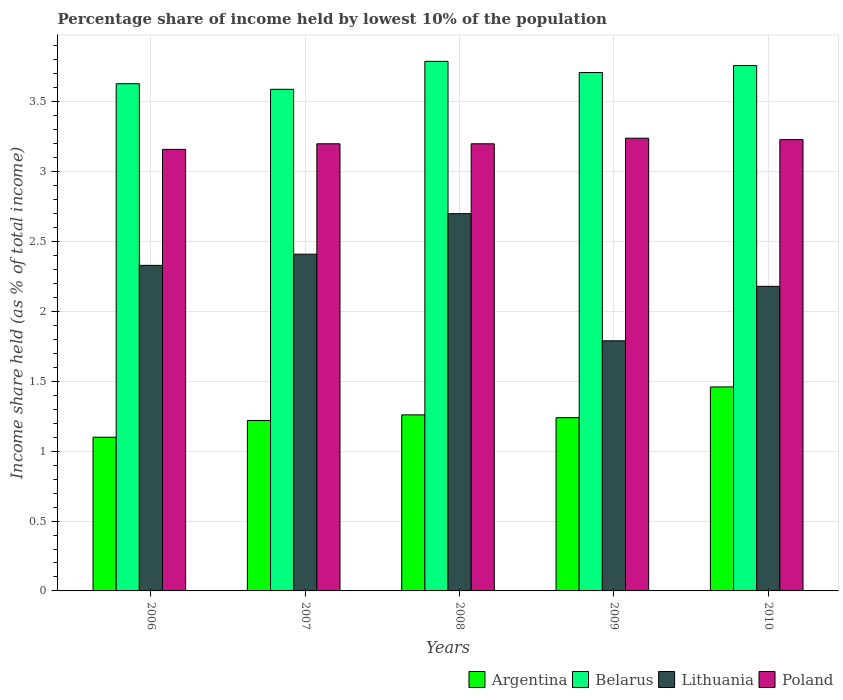How many bars are there on the 3rd tick from the left?
Offer a very short reply. 4. What is the percentage share of income held by lowest 10% of the population in Belarus in 2010?
Offer a very short reply. 3.76. Across all years, what is the minimum percentage share of income held by lowest 10% of the population in Poland?
Provide a succinct answer. 3.16. In which year was the percentage share of income held by lowest 10% of the population in Belarus maximum?
Provide a succinct answer. 2008. In which year was the percentage share of income held by lowest 10% of the population in Belarus minimum?
Your response must be concise. 2007. What is the total percentage share of income held by lowest 10% of the population in Belarus in the graph?
Provide a short and direct response. 18.48. What is the difference between the percentage share of income held by lowest 10% of the population in Poland in 2008 and that in 2010?
Ensure brevity in your answer.  -0.03. What is the difference between the percentage share of income held by lowest 10% of the population in Argentina in 2008 and the percentage share of income held by lowest 10% of the population in Lithuania in 2006?
Your answer should be very brief. -1.07. What is the average percentage share of income held by lowest 10% of the population in Belarus per year?
Ensure brevity in your answer.  3.7. In the year 2007, what is the difference between the percentage share of income held by lowest 10% of the population in Poland and percentage share of income held by lowest 10% of the population in Belarus?
Keep it short and to the point. -0.39. In how many years, is the percentage share of income held by lowest 10% of the population in Argentina greater than 3.8 %?
Keep it short and to the point. 0. What is the ratio of the percentage share of income held by lowest 10% of the population in Poland in 2006 to that in 2007?
Provide a succinct answer. 0.99. Is the percentage share of income held by lowest 10% of the population in Poland in 2007 less than that in 2008?
Ensure brevity in your answer.  No. What is the difference between the highest and the second highest percentage share of income held by lowest 10% of the population in Poland?
Make the answer very short. 0.01. What is the difference between the highest and the lowest percentage share of income held by lowest 10% of the population in Lithuania?
Your answer should be compact. 0.91. In how many years, is the percentage share of income held by lowest 10% of the population in Lithuania greater than the average percentage share of income held by lowest 10% of the population in Lithuania taken over all years?
Offer a very short reply. 3. Is it the case that in every year, the sum of the percentage share of income held by lowest 10% of the population in Argentina and percentage share of income held by lowest 10% of the population in Poland is greater than the sum of percentage share of income held by lowest 10% of the population in Belarus and percentage share of income held by lowest 10% of the population in Lithuania?
Provide a succinct answer. No. What does the 2nd bar from the left in 2009 represents?
Provide a succinct answer. Belarus. How many bars are there?
Your answer should be very brief. 20. How many years are there in the graph?
Ensure brevity in your answer.  5. What is the difference between two consecutive major ticks on the Y-axis?
Make the answer very short. 0.5. Are the values on the major ticks of Y-axis written in scientific E-notation?
Your response must be concise. No. Does the graph contain any zero values?
Your answer should be compact. No. Does the graph contain grids?
Ensure brevity in your answer.  Yes. What is the title of the graph?
Ensure brevity in your answer.  Percentage share of income held by lowest 10% of the population. What is the label or title of the Y-axis?
Provide a short and direct response. Income share held (as % of total income). What is the Income share held (as % of total income) of Argentina in 2006?
Ensure brevity in your answer.  1.1. What is the Income share held (as % of total income) in Belarus in 2006?
Your response must be concise. 3.63. What is the Income share held (as % of total income) of Lithuania in 2006?
Your answer should be very brief. 2.33. What is the Income share held (as % of total income) of Poland in 2006?
Keep it short and to the point. 3.16. What is the Income share held (as % of total income) in Argentina in 2007?
Give a very brief answer. 1.22. What is the Income share held (as % of total income) of Belarus in 2007?
Make the answer very short. 3.59. What is the Income share held (as % of total income) of Lithuania in 2007?
Your answer should be compact. 2.41. What is the Income share held (as % of total income) in Argentina in 2008?
Provide a short and direct response. 1.26. What is the Income share held (as % of total income) in Belarus in 2008?
Your answer should be very brief. 3.79. What is the Income share held (as % of total income) of Poland in 2008?
Keep it short and to the point. 3.2. What is the Income share held (as % of total income) in Argentina in 2009?
Your response must be concise. 1.24. What is the Income share held (as % of total income) in Belarus in 2009?
Offer a very short reply. 3.71. What is the Income share held (as % of total income) in Lithuania in 2009?
Keep it short and to the point. 1.79. What is the Income share held (as % of total income) in Poland in 2009?
Provide a short and direct response. 3.24. What is the Income share held (as % of total income) in Argentina in 2010?
Your answer should be very brief. 1.46. What is the Income share held (as % of total income) of Belarus in 2010?
Provide a succinct answer. 3.76. What is the Income share held (as % of total income) of Lithuania in 2010?
Offer a terse response. 2.18. What is the Income share held (as % of total income) in Poland in 2010?
Offer a very short reply. 3.23. Across all years, what is the maximum Income share held (as % of total income) of Argentina?
Keep it short and to the point. 1.46. Across all years, what is the maximum Income share held (as % of total income) in Belarus?
Make the answer very short. 3.79. Across all years, what is the maximum Income share held (as % of total income) of Lithuania?
Offer a terse response. 2.7. Across all years, what is the maximum Income share held (as % of total income) of Poland?
Keep it short and to the point. 3.24. Across all years, what is the minimum Income share held (as % of total income) in Argentina?
Provide a succinct answer. 1.1. Across all years, what is the minimum Income share held (as % of total income) of Belarus?
Ensure brevity in your answer.  3.59. Across all years, what is the minimum Income share held (as % of total income) in Lithuania?
Provide a succinct answer. 1.79. Across all years, what is the minimum Income share held (as % of total income) in Poland?
Provide a short and direct response. 3.16. What is the total Income share held (as % of total income) of Argentina in the graph?
Your answer should be very brief. 6.28. What is the total Income share held (as % of total income) of Belarus in the graph?
Keep it short and to the point. 18.48. What is the total Income share held (as % of total income) of Lithuania in the graph?
Give a very brief answer. 11.41. What is the total Income share held (as % of total income) in Poland in the graph?
Ensure brevity in your answer.  16.03. What is the difference between the Income share held (as % of total income) of Argentina in 2006 and that in 2007?
Provide a succinct answer. -0.12. What is the difference between the Income share held (as % of total income) of Belarus in 2006 and that in 2007?
Ensure brevity in your answer.  0.04. What is the difference between the Income share held (as % of total income) of Lithuania in 2006 and that in 2007?
Provide a succinct answer. -0.08. What is the difference between the Income share held (as % of total income) in Poland in 2006 and that in 2007?
Make the answer very short. -0.04. What is the difference between the Income share held (as % of total income) of Argentina in 2006 and that in 2008?
Offer a very short reply. -0.16. What is the difference between the Income share held (as % of total income) of Belarus in 2006 and that in 2008?
Make the answer very short. -0.16. What is the difference between the Income share held (as % of total income) of Lithuania in 2006 and that in 2008?
Your answer should be compact. -0.37. What is the difference between the Income share held (as % of total income) in Poland in 2006 and that in 2008?
Provide a succinct answer. -0.04. What is the difference between the Income share held (as % of total income) in Argentina in 2006 and that in 2009?
Ensure brevity in your answer.  -0.14. What is the difference between the Income share held (as % of total income) in Belarus in 2006 and that in 2009?
Provide a short and direct response. -0.08. What is the difference between the Income share held (as % of total income) in Lithuania in 2006 and that in 2009?
Your answer should be very brief. 0.54. What is the difference between the Income share held (as % of total income) of Poland in 2006 and that in 2009?
Offer a terse response. -0.08. What is the difference between the Income share held (as % of total income) of Argentina in 2006 and that in 2010?
Ensure brevity in your answer.  -0.36. What is the difference between the Income share held (as % of total income) in Belarus in 2006 and that in 2010?
Keep it short and to the point. -0.13. What is the difference between the Income share held (as % of total income) in Poland in 2006 and that in 2010?
Keep it short and to the point. -0.07. What is the difference between the Income share held (as % of total income) in Argentina in 2007 and that in 2008?
Provide a short and direct response. -0.04. What is the difference between the Income share held (as % of total income) of Lithuania in 2007 and that in 2008?
Offer a terse response. -0.29. What is the difference between the Income share held (as % of total income) in Poland in 2007 and that in 2008?
Your answer should be very brief. 0. What is the difference between the Income share held (as % of total income) in Argentina in 2007 and that in 2009?
Make the answer very short. -0.02. What is the difference between the Income share held (as % of total income) of Belarus in 2007 and that in 2009?
Provide a succinct answer. -0.12. What is the difference between the Income share held (as % of total income) of Lithuania in 2007 and that in 2009?
Your answer should be compact. 0.62. What is the difference between the Income share held (as % of total income) of Poland in 2007 and that in 2009?
Provide a succinct answer. -0.04. What is the difference between the Income share held (as % of total income) in Argentina in 2007 and that in 2010?
Make the answer very short. -0.24. What is the difference between the Income share held (as % of total income) of Belarus in 2007 and that in 2010?
Keep it short and to the point. -0.17. What is the difference between the Income share held (as % of total income) of Lithuania in 2007 and that in 2010?
Give a very brief answer. 0.23. What is the difference between the Income share held (as % of total income) of Poland in 2007 and that in 2010?
Your answer should be compact. -0.03. What is the difference between the Income share held (as % of total income) of Argentina in 2008 and that in 2009?
Offer a terse response. 0.02. What is the difference between the Income share held (as % of total income) in Belarus in 2008 and that in 2009?
Ensure brevity in your answer.  0.08. What is the difference between the Income share held (as % of total income) in Lithuania in 2008 and that in 2009?
Keep it short and to the point. 0.91. What is the difference between the Income share held (as % of total income) in Poland in 2008 and that in 2009?
Provide a succinct answer. -0.04. What is the difference between the Income share held (as % of total income) of Belarus in 2008 and that in 2010?
Ensure brevity in your answer.  0.03. What is the difference between the Income share held (as % of total income) in Lithuania in 2008 and that in 2010?
Give a very brief answer. 0.52. What is the difference between the Income share held (as % of total income) of Poland in 2008 and that in 2010?
Provide a succinct answer. -0.03. What is the difference between the Income share held (as % of total income) in Argentina in 2009 and that in 2010?
Provide a short and direct response. -0.22. What is the difference between the Income share held (as % of total income) of Lithuania in 2009 and that in 2010?
Your answer should be very brief. -0.39. What is the difference between the Income share held (as % of total income) in Poland in 2009 and that in 2010?
Your answer should be compact. 0.01. What is the difference between the Income share held (as % of total income) in Argentina in 2006 and the Income share held (as % of total income) in Belarus in 2007?
Provide a short and direct response. -2.49. What is the difference between the Income share held (as % of total income) in Argentina in 2006 and the Income share held (as % of total income) in Lithuania in 2007?
Make the answer very short. -1.31. What is the difference between the Income share held (as % of total income) of Belarus in 2006 and the Income share held (as % of total income) of Lithuania in 2007?
Your response must be concise. 1.22. What is the difference between the Income share held (as % of total income) in Belarus in 2006 and the Income share held (as % of total income) in Poland in 2007?
Keep it short and to the point. 0.43. What is the difference between the Income share held (as % of total income) in Lithuania in 2006 and the Income share held (as % of total income) in Poland in 2007?
Ensure brevity in your answer.  -0.87. What is the difference between the Income share held (as % of total income) of Argentina in 2006 and the Income share held (as % of total income) of Belarus in 2008?
Provide a succinct answer. -2.69. What is the difference between the Income share held (as % of total income) in Argentina in 2006 and the Income share held (as % of total income) in Lithuania in 2008?
Make the answer very short. -1.6. What is the difference between the Income share held (as % of total income) of Belarus in 2006 and the Income share held (as % of total income) of Lithuania in 2008?
Give a very brief answer. 0.93. What is the difference between the Income share held (as % of total income) of Belarus in 2006 and the Income share held (as % of total income) of Poland in 2008?
Keep it short and to the point. 0.43. What is the difference between the Income share held (as % of total income) of Lithuania in 2006 and the Income share held (as % of total income) of Poland in 2008?
Provide a succinct answer. -0.87. What is the difference between the Income share held (as % of total income) of Argentina in 2006 and the Income share held (as % of total income) of Belarus in 2009?
Keep it short and to the point. -2.61. What is the difference between the Income share held (as % of total income) of Argentina in 2006 and the Income share held (as % of total income) of Lithuania in 2009?
Provide a succinct answer. -0.69. What is the difference between the Income share held (as % of total income) of Argentina in 2006 and the Income share held (as % of total income) of Poland in 2009?
Your answer should be very brief. -2.14. What is the difference between the Income share held (as % of total income) of Belarus in 2006 and the Income share held (as % of total income) of Lithuania in 2009?
Make the answer very short. 1.84. What is the difference between the Income share held (as % of total income) in Belarus in 2006 and the Income share held (as % of total income) in Poland in 2009?
Offer a terse response. 0.39. What is the difference between the Income share held (as % of total income) of Lithuania in 2006 and the Income share held (as % of total income) of Poland in 2009?
Offer a very short reply. -0.91. What is the difference between the Income share held (as % of total income) in Argentina in 2006 and the Income share held (as % of total income) in Belarus in 2010?
Offer a very short reply. -2.66. What is the difference between the Income share held (as % of total income) in Argentina in 2006 and the Income share held (as % of total income) in Lithuania in 2010?
Provide a succinct answer. -1.08. What is the difference between the Income share held (as % of total income) of Argentina in 2006 and the Income share held (as % of total income) of Poland in 2010?
Make the answer very short. -2.13. What is the difference between the Income share held (as % of total income) of Belarus in 2006 and the Income share held (as % of total income) of Lithuania in 2010?
Give a very brief answer. 1.45. What is the difference between the Income share held (as % of total income) of Belarus in 2006 and the Income share held (as % of total income) of Poland in 2010?
Your response must be concise. 0.4. What is the difference between the Income share held (as % of total income) in Argentina in 2007 and the Income share held (as % of total income) in Belarus in 2008?
Give a very brief answer. -2.57. What is the difference between the Income share held (as % of total income) in Argentina in 2007 and the Income share held (as % of total income) in Lithuania in 2008?
Offer a terse response. -1.48. What is the difference between the Income share held (as % of total income) of Argentina in 2007 and the Income share held (as % of total income) of Poland in 2008?
Provide a succinct answer. -1.98. What is the difference between the Income share held (as % of total income) in Belarus in 2007 and the Income share held (as % of total income) in Lithuania in 2008?
Offer a very short reply. 0.89. What is the difference between the Income share held (as % of total income) of Belarus in 2007 and the Income share held (as % of total income) of Poland in 2008?
Make the answer very short. 0.39. What is the difference between the Income share held (as % of total income) in Lithuania in 2007 and the Income share held (as % of total income) in Poland in 2008?
Make the answer very short. -0.79. What is the difference between the Income share held (as % of total income) in Argentina in 2007 and the Income share held (as % of total income) in Belarus in 2009?
Offer a terse response. -2.49. What is the difference between the Income share held (as % of total income) of Argentina in 2007 and the Income share held (as % of total income) of Lithuania in 2009?
Make the answer very short. -0.57. What is the difference between the Income share held (as % of total income) in Argentina in 2007 and the Income share held (as % of total income) in Poland in 2009?
Your answer should be compact. -2.02. What is the difference between the Income share held (as % of total income) in Belarus in 2007 and the Income share held (as % of total income) in Lithuania in 2009?
Your answer should be compact. 1.8. What is the difference between the Income share held (as % of total income) in Lithuania in 2007 and the Income share held (as % of total income) in Poland in 2009?
Ensure brevity in your answer.  -0.83. What is the difference between the Income share held (as % of total income) of Argentina in 2007 and the Income share held (as % of total income) of Belarus in 2010?
Provide a succinct answer. -2.54. What is the difference between the Income share held (as % of total income) in Argentina in 2007 and the Income share held (as % of total income) in Lithuania in 2010?
Offer a terse response. -0.96. What is the difference between the Income share held (as % of total income) in Argentina in 2007 and the Income share held (as % of total income) in Poland in 2010?
Offer a very short reply. -2.01. What is the difference between the Income share held (as % of total income) in Belarus in 2007 and the Income share held (as % of total income) in Lithuania in 2010?
Make the answer very short. 1.41. What is the difference between the Income share held (as % of total income) in Belarus in 2007 and the Income share held (as % of total income) in Poland in 2010?
Your answer should be compact. 0.36. What is the difference between the Income share held (as % of total income) in Lithuania in 2007 and the Income share held (as % of total income) in Poland in 2010?
Give a very brief answer. -0.82. What is the difference between the Income share held (as % of total income) in Argentina in 2008 and the Income share held (as % of total income) in Belarus in 2009?
Offer a very short reply. -2.45. What is the difference between the Income share held (as % of total income) in Argentina in 2008 and the Income share held (as % of total income) in Lithuania in 2009?
Offer a terse response. -0.53. What is the difference between the Income share held (as % of total income) in Argentina in 2008 and the Income share held (as % of total income) in Poland in 2009?
Offer a very short reply. -1.98. What is the difference between the Income share held (as % of total income) of Belarus in 2008 and the Income share held (as % of total income) of Poland in 2009?
Your answer should be compact. 0.55. What is the difference between the Income share held (as % of total income) in Lithuania in 2008 and the Income share held (as % of total income) in Poland in 2009?
Provide a short and direct response. -0.54. What is the difference between the Income share held (as % of total income) of Argentina in 2008 and the Income share held (as % of total income) of Belarus in 2010?
Your answer should be very brief. -2.5. What is the difference between the Income share held (as % of total income) of Argentina in 2008 and the Income share held (as % of total income) of Lithuania in 2010?
Offer a terse response. -0.92. What is the difference between the Income share held (as % of total income) in Argentina in 2008 and the Income share held (as % of total income) in Poland in 2010?
Keep it short and to the point. -1.97. What is the difference between the Income share held (as % of total income) in Belarus in 2008 and the Income share held (as % of total income) in Lithuania in 2010?
Ensure brevity in your answer.  1.61. What is the difference between the Income share held (as % of total income) of Belarus in 2008 and the Income share held (as % of total income) of Poland in 2010?
Offer a very short reply. 0.56. What is the difference between the Income share held (as % of total income) of Lithuania in 2008 and the Income share held (as % of total income) of Poland in 2010?
Your answer should be very brief. -0.53. What is the difference between the Income share held (as % of total income) in Argentina in 2009 and the Income share held (as % of total income) in Belarus in 2010?
Provide a succinct answer. -2.52. What is the difference between the Income share held (as % of total income) of Argentina in 2009 and the Income share held (as % of total income) of Lithuania in 2010?
Your answer should be compact. -0.94. What is the difference between the Income share held (as % of total income) of Argentina in 2009 and the Income share held (as % of total income) of Poland in 2010?
Keep it short and to the point. -1.99. What is the difference between the Income share held (as % of total income) in Belarus in 2009 and the Income share held (as % of total income) in Lithuania in 2010?
Offer a terse response. 1.53. What is the difference between the Income share held (as % of total income) in Belarus in 2009 and the Income share held (as % of total income) in Poland in 2010?
Offer a terse response. 0.48. What is the difference between the Income share held (as % of total income) in Lithuania in 2009 and the Income share held (as % of total income) in Poland in 2010?
Make the answer very short. -1.44. What is the average Income share held (as % of total income) of Argentina per year?
Provide a short and direct response. 1.26. What is the average Income share held (as % of total income) of Belarus per year?
Offer a terse response. 3.7. What is the average Income share held (as % of total income) of Lithuania per year?
Provide a succinct answer. 2.28. What is the average Income share held (as % of total income) in Poland per year?
Provide a succinct answer. 3.21. In the year 2006, what is the difference between the Income share held (as % of total income) of Argentina and Income share held (as % of total income) of Belarus?
Your answer should be very brief. -2.53. In the year 2006, what is the difference between the Income share held (as % of total income) of Argentina and Income share held (as % of total income) of Lithuania?
Offer a very short reply. -1.23. In the year 2006, what is the difference between the Income share held (as % of total income) of Argentina and Income share held (as % of total income) of Poland?
Make the answer very short. -2.06. In the year 2006, what is the difference between the Income share held (as % of total income) of Belarus and Income share held (as % of total income) of Poland?
Your answer should be very brief. 0.47. In the year 2006, what is the difference between the Income share held (as % of total income) in Lithuania and Income share held (as % of total income) in Poland?
Give a very brief answer. -0.83. In the year 2007, what is the difference between the Income share held (as % of total income) of Argentina and Income share held (as % of total income) of Belarus?
Your answer should be compact. -2.37. In the year 2007, what is the difference between the Income share held (as % of total income) of Argentina and Income share held (as % of total income) of Lithuania?
Provide a succinct answer. -1.19. In the year 2007, what is the difference between the Income share held (as % of total income) of Argentina and Income share held (as % of total income) of Poland?
Provide a short and direct response. -1.98. In the year 2007, what is the difference between the Income share held (as % of total income) in Belarus and Income share held (as % of total income) in Lithuania?
Ensure brevity in your answer.  1.18. In the year 2007, what is the difference between the Income share held (as % of total income) in Belarus and Income share held (as % of total income) in Poland?
Offer a terse response. 0.39. In the year 2007, what is the difference between the Income share held (as % of total income) of Lithuania and Income share held (as % of total income) of Poland?
Offer a terse response. -0.79. In the year 2008, what is the difference between the Income share held (as % of total income) of Argentina and Income share held (as % of total income) of Belarus?
Provide a succinct answer. -2.53. In the year 2008, what is the difference between the Income share held (as % of total income) in Argentina and Income share held (as % of total income) in Lithuania?
Provide a short and direct response. -1.44. In the year 2008, what is the difference between the Income share held (as % of total income) of Argentina and Income share held (as % of total income) of Poland?
Keep it short and to the point. -1.94. In the year 2008, what is the difference between the Income share held (as % of total income) in Belarus and Income share held (as % of total income) in Lithuania?
Your answer should be compact. 1.09. In the year 2008, what is the difference between the Income share held (as % of total income) of Belarus and Income share held (as % of total income) of Poland?
Ensure brevity in your answer.  0.59. In the year 2008, what is the difference between the Income share held (as % of total income) of Lithuania and Income share held (as % of total income) of Poland?
Keep it short and to the point. -0.5. In the year 2009, what is the difference between the Income share held (as % of total income) of Argentina and Income share held (as % of total income) of Belarus?
Offer a terse response. -2.47. In the year 2009, what is the difference between the Income share held (as % of total income) of Argentina and Income share held (as % of total income) of Lithuania?
Keep it short and to the point. -0.55. In the year 2009, what is the difference between the Income share held (as % of total income) of Argentina and Income share held (as % of total income) of Poland?
Your response must be concise. -2. In the year 2009, what is the difference between the Income share held (as % of total income) in Belarus and Income share held (as % of total income) in Lithuania?
Make the answer very short. 1.92. In the year 2009, what is the difference between the Income share held (as % of total income) of Belarus and Income share held (as % of total income) of Poland?
Make the answer very short. 0.47. In the year 2009, what is the difference between the Income share held (as % of total income) in Lithuania and Income share held (as % of total income) in Poland?
Offer a very short reply. -1.45. In the year 2010, what is the difference between the Income share held (as % of total income) of Argentina and Income share held (as % of total income) of Lithuania?
Your response must be concise. -0.72. In the year 2010, what is the difference between the Income share held (as % of total income) of Argentina and Income share held (as % of total income) of Poland?
Your answer should be very brief. -1.77. In the year 2010, what is the difference between the Income share held (as % of total income) of Belarus and Income share held (as % of total income) of Lithuania?
Offer a terse response. 1.58. In the year 2010, what is the difference between the Income share held (as % of total income) in Belarus and Income share held (as % of total income) in Poland?
Your response must be concise. 0.53. In the year 2010, what is the difference between the Income share held (as % of total income) in Lithuania and Income share held (as % of total income) in Poland?
Keep it short and to the point. -1.05. What is the ratio of the Income share held (as % of total income) in Argentina in 2006 to that in 2007?
Offer a terse response. 0.9. What is the ratio of the Income share held (as % of total income) in Belarus in 2006 to that in 2007?
Your answer should be compact. 1.01. What is the ratio of the Income share held (as % of total income) of Lithuania in 2006 to that in 2007?
Offer a very short reply. 0.97. What is the ratio of the Income share held (as % of total income) in Poland in 2006 to that in 2007?
Keep it short and to the point. 0.99. What is the ratio of the Income share held (as % of total income) in Argentina in 2006 to that in 2008?
Provide a succinct answer. 0.87. What is the ratio of the Income share held (as % of total income) in Belarus in 2006 to that in 2008?
Offer a very short reply. 0.96. What is the ratio of the Income share held (as % of total income) of Lithuania in 2006 to that in 2008?
Give a very brief answer. 0.86. What is the ratio of the Income share held (as % of total income) in Poland in 2006 to that in 2008?
Make the answer very short. 0.99. What is the ratio of the Income share held (as % of total income) of Argentina in 2006 to that in 2009?
Ensure brevity in your answer.  0.89. What is the ratio of the Income share held (as % of total income) in Belarus in 2006 to that in 2009?
Your answer should be very brief. 0.98. What is the ratio of the Income share held (as % of total income) of Lithuania in 2006 to that in 2009?
Offer a terse response. 1.3. What is the ratio of the Income share held (as % of total income) in Poland in 2006 to that in 2009?
Provide a succinct answer. 0.98. What is the ratio of the Income share held (as % of total income) in Argentina in 2006 to that in 2010?
Offer a very short reply. 0.75. What is the ratio of the Income share held (as % of total income) of Belarus in 2006 to that in 2010?
Provide a short and direct response. 0.97. What is the ratio of the Income share held (as % of total income) of Lithuania in 2006 to that in 2010?
Your answer should be compact. 1.07. What is the ratio of the Income share held (as % of total income) in Poland in 2006 to that in 2010?
Offer a terse response. 0.98. What is the ratio of the Income share held (as % of total income) in Argentina in 2007 to that in 2008?
Your answer should be very brief. 0.97. What is the ratio of the Income share held (as % of total income) in Belarus in 2007 to that in 2008?
Ensure brevity in your answer.  0.95. What is the ratio of the Income share held (as % of total income) of Lithuania in 2007 to that in 2008?
Make the answer very short. 0.89. What is the ratio of the Income share held (as % of total income) in Argentina in 2007 to that in 2009?
Keep it short and to the point. 0.98. What is the ratio of the Income share held (as % of total income) in Belarus in 2007 to that in 2009?
Offer a very short reply. 0.97. What is the ratio of the Income share held (as % of total income) of Lithuania in 2007 to that in 2009?
Give a very brief answer. 1.35. What is the ratio of the Income share held (as % of total income) in Argentina in 2007 to that in 2010?
Offer a terse response. 0.84. What is the ratio of the Income share held (as % of total income) in Belarus in 2007 to that in 2010?
Ensure brevity in your answer.  0.95. What is the ratio of the Income share held (as % of total income) of Lithuania in 2007 to that in 2010?
Keep it short and to the point. 1.11. What is the ratio of the Income share held (as % of total income) of Poland in 2007 to that in 2010?
Your answer should be compact. 0.99. What is the ratio of the Income share held (as % of total income) in Argentina in 2008 to that in 2009?
Give a very brief answer. 1.02. What is the ratio of the Income share held (as % of total income) of Belarus in 2008 to that in 2009?
Your answer should be very brief. 1.02. What is the ratio of the Income share held (as % of total income) of Lithuania in 2008 to that in 2009?
Give a very brief answer. 1.51. What is the ratio of the Income share held (as % of total income) of Argentina in 2008 to that in 2010?
Offer a terse response. 0.86. What is the ratio of the Income share held (as % of total income) of Belarus in 2008 to that in 2010?
Ensure brevity in your answer.  1.01. What is the ratio of the Income share held (as % of total income) in Lithuania in 2008 to that in 2010?
Your answer should be compact. 1.24. What is the ratio of the Income share held (as % of total income) of Poland in 2008 to that in 2010?
Ensure brevity in your answer.  0.99. What is the ratio of the Income share held (as % of total income) in Argentina in 2009 to that in 2010?
Keep it short and to the point. 0.85. What is the ratio of the Income share held (as % of total income) of Belarus in 2009 to that in 2010?
Your answer should be compact. 0.99. What is the ratio of the Income share held (as % of total income) in Lithuania in 2009 to that in 2010?
Offer a terse response. 0.82. What is the difference between the highest and the second highest Income share held (as % of total income) in Lithuania?
Provide a succinct answer. 0.29. What is the difference between the highest and the lowest Income share held (as % of total income) of Argentina?
Make the answer very short. 0.36. What is the difference between the highest and the lowest Income share held (as % of total income) of Belarus?
Your response must be concise. 0.2. What is the difference between the highest and the lowest Income share held (as % of total income) in Lithuania?
Give a very brief answer. 0.91. What is the difference between the highest and the lowest Income share held (as % of total income) of Poland?
Your answer should be compact. 0.08. 